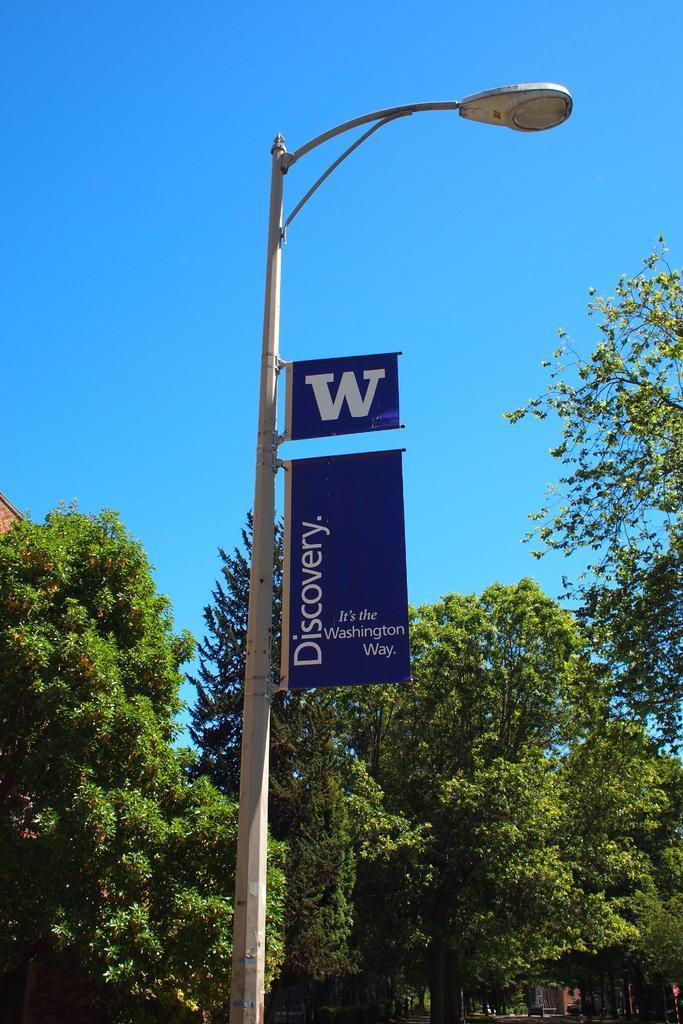How would you summarize this image in a sentence or two? In the foreground we can see a street light and boards. In the middle of the picture there are trees and buildings. At the top it is sky. 